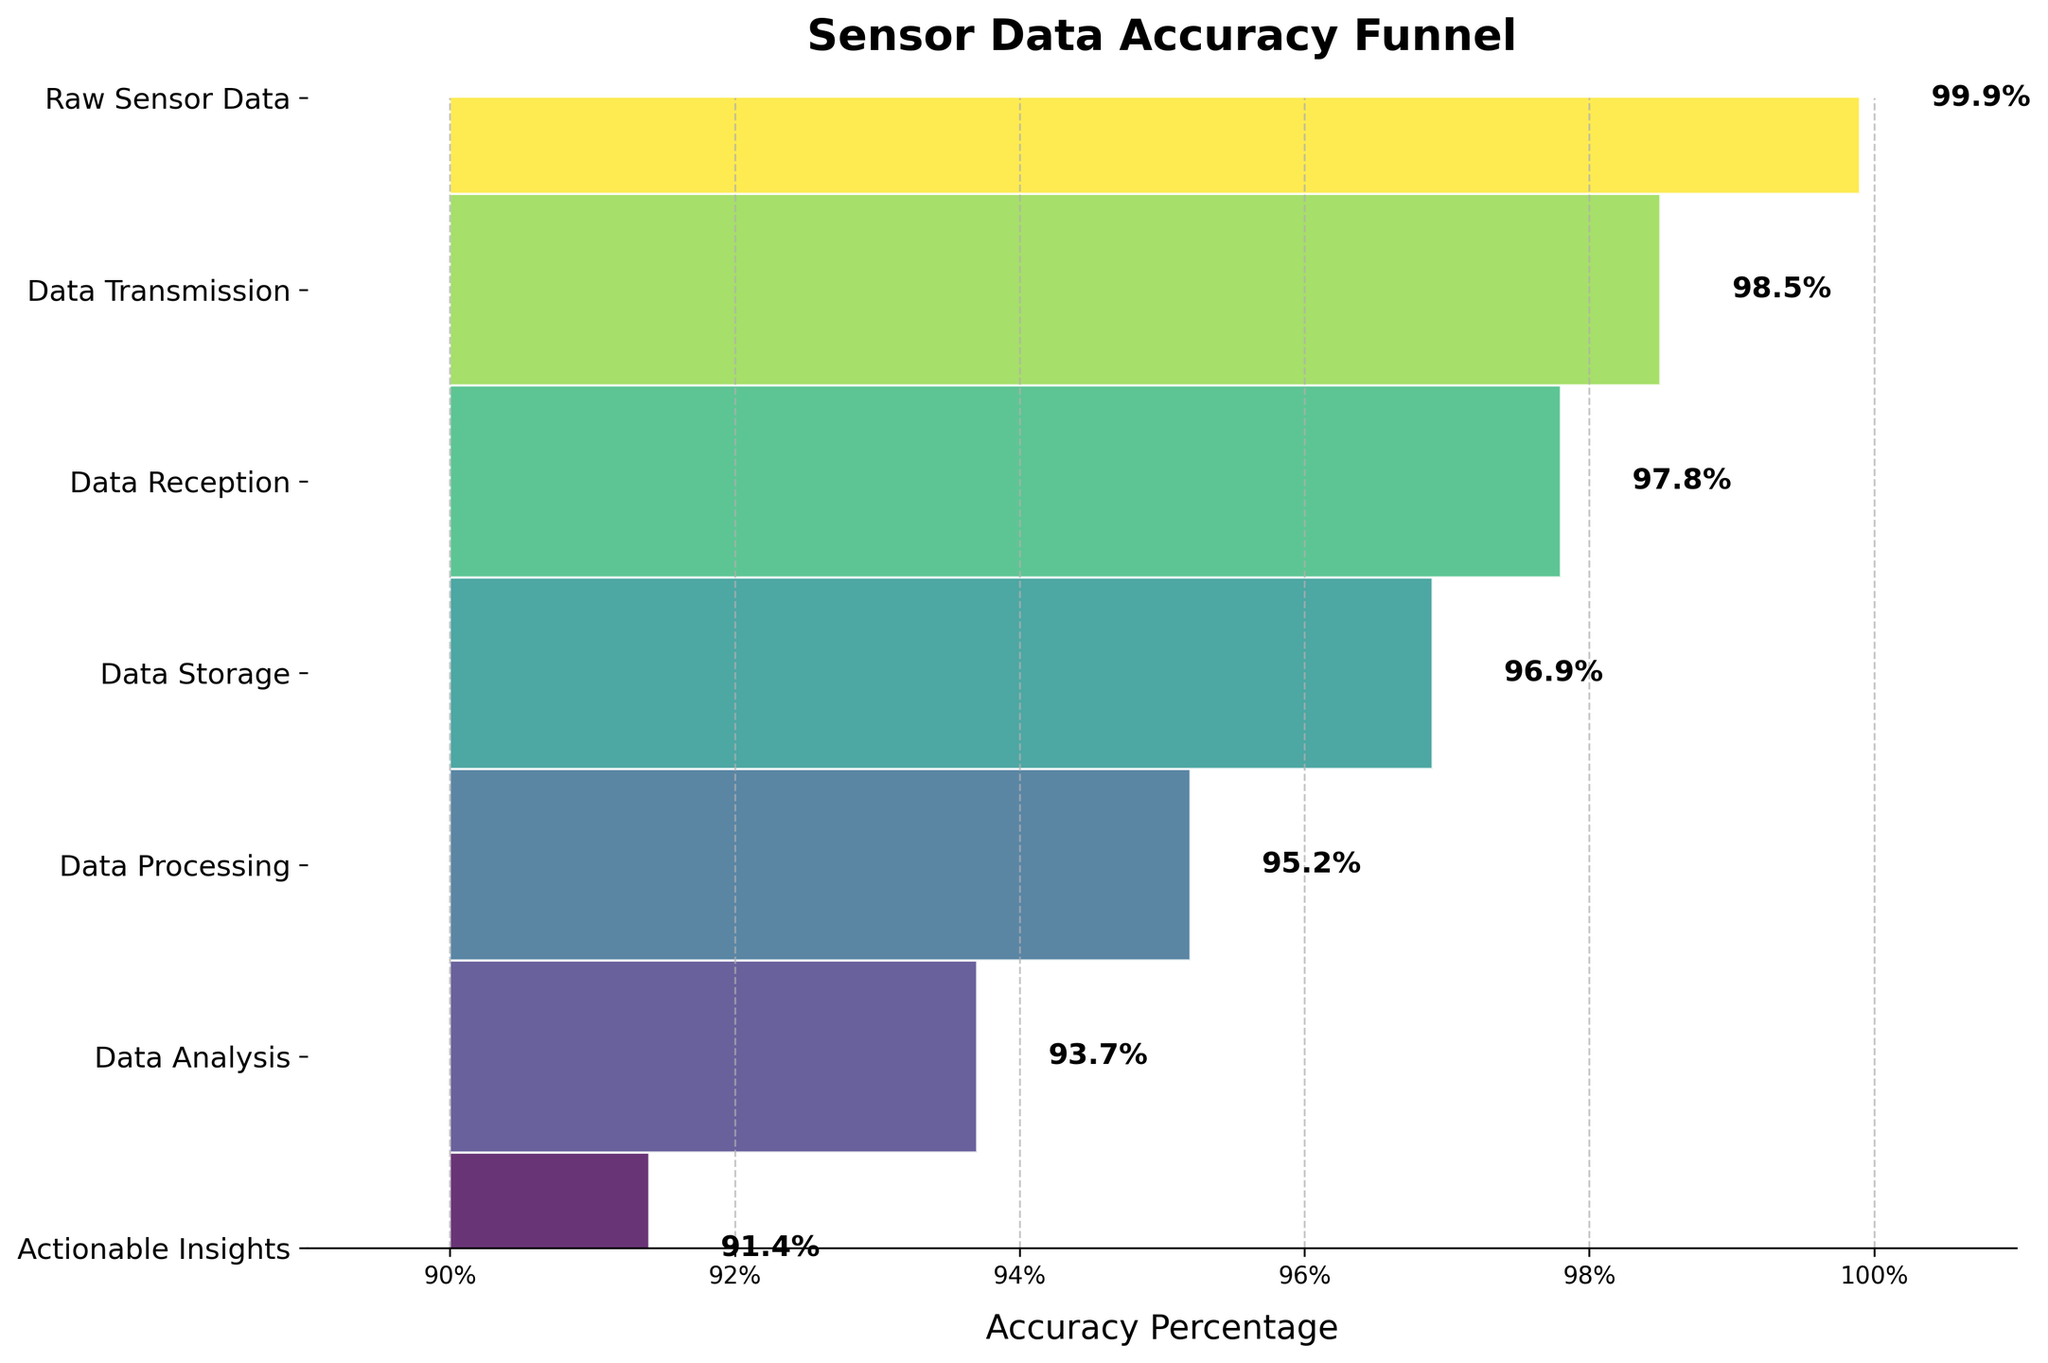What is the title of the figure? The title is displayed at the top of the figure in bold and larger font, indicating the main idea the chart is conveying.
Answer: Sensor Data Accuracy Funnel Which stage has the highest accuracy percentage? The stage with the highest percentage is at the top of the funnel, showing the best performance.
Answer: Raw Sensor Data What is the accuracy percentage difference between Data Transmission and Data Storage? Identify the percentages for both Data Transmission (98.5%) and Data Storage (96.9%), then subtract the latter from the former: 98.5 - 96.9.
Answer: 1.6 Which stage shows the least decline in accuracy percentage compared to the previous stage? Check the percentage drop between consecutive stages and identify the smallest difference. Between Data Transmission and Data Reception, the decline is 98.5 - 97.8 = 0.7, which is the smallest.
Answer: Data Reception What is the average accuracy percentage across all stages? Add all the accuracy percentages (99.9 + 98.5 + 97.8 + 96.9 + 95.2 + 93.7 + 91.4) and divide by the number of stages (7).
Answer: 96.2 How much does the accuracy percentage drop from Raw Sensor Data to Actionable Insights? Subtract the percentage of Actionable Insights (91.4%) from Raw Sensor Data (99.9%): 99.9 - 91.4.
Answer: 8.5 What is the trend shown in the figure as data moves from Raw Sensor Data to Actionable Insights? Observe the pattern of the bars in the funnel chart, which generally decrease from top to bottom.
Answer: The accuracy percentage decreases Which two consecutive stages have the largest drop in accuracy percentage? Calculate the differences between consecutive stages and find the largest one. Data Processing (95.2%) to Data Analysis (93.7%) shows the largest drop of 1.5 (95.2 - 93.7).
Answer: Data Processing to Data Analysis 